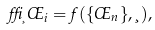<formula> <loc_0><loc_0><loc_500><loc_500>\delta _ { \xi } \phi _ { i } = f ( \{ \phi _ { n } \} , \xi ) ,</formula> 